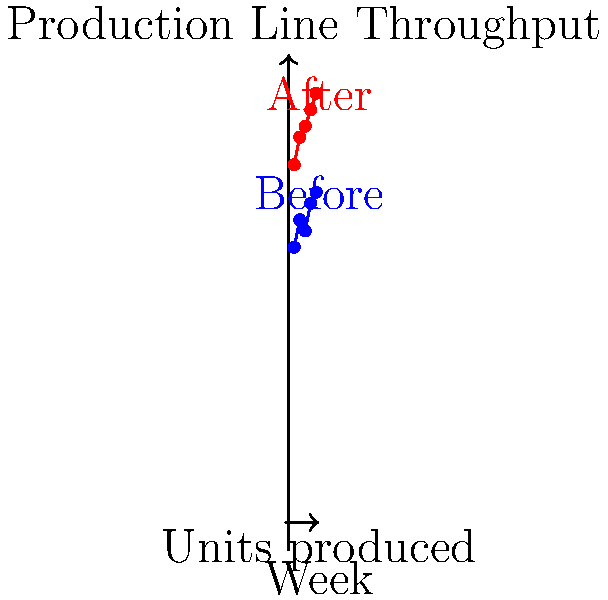Based on the chart showing production line throughput before and after introducing a new robotic arm, calculate the percentage increase in average weekly production from the 'Before' period to the 'After' period. To calculate the percentage increase in average weekly production, we need to follow these steps:

1. Calculate the average weekly production for the 'Before' period:
   $\text{Before Average} = \frac{50 + 55 + 53 + 58 + 60}{5} = 55.2$ units

2. Calculate the average weekly production for the 'After' period:
   $\text{After Average} = \frac{65 + 70 + 72 + 75 + 78}{5} = 72$ units

3. Calculate the difference between the two averages:
   $\text{Difference} = 72 - 55.2 = 16.8$ units

4. Calculate the percentage increase:
   $\text{Percentage Increase} = \frac{\text{Difference}}{\text{Before Average}} \times 100\%$
   $= \frac{16.8}{55.2} \times 100\% = 0.3043 \times 100\% = 30.43\%$

Therefore, the percentage increase in average weekly production from the 'Before' period to the 'After' period is approximately 30.43%.
Answer: 30.43% 